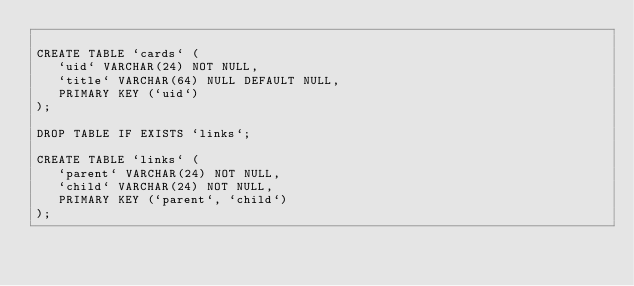<code> <loc_0><loc_0><loc_500><loc_500><_SQL_>
CREATE TABLE `cards` (
   `uid` VARCHAR(24) NOT NULL,
   `title` VARCHAR(64) NULL DEFAULT NULL,
   PRIMARY KEY (`uid`)
);

DROP TABLE IF EXISTS `links`;

CREATE TABLE `links` (
   `parent` VARCHAR(24) NOT NULL,
   `child` VARCHAR(24) NOT NULL,
   PRIMARY KEY (`parent`, `child`)
);
</code> 